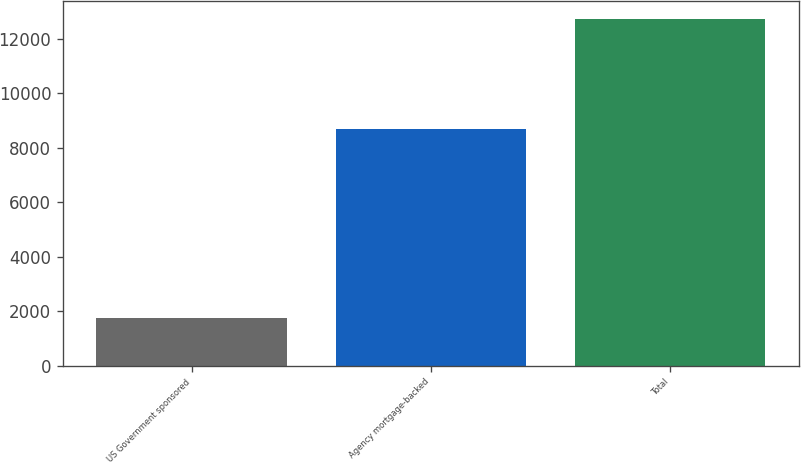Convert chart. <chart><loc_0><loc_0><loc_500><loc_500><bar_chart><fcel>US Government sponsored<fcel>Agency mortgage-backed<fcel>Total<nl><fcel>1730<fcel>8681<fcel>12728<nl></chart> 